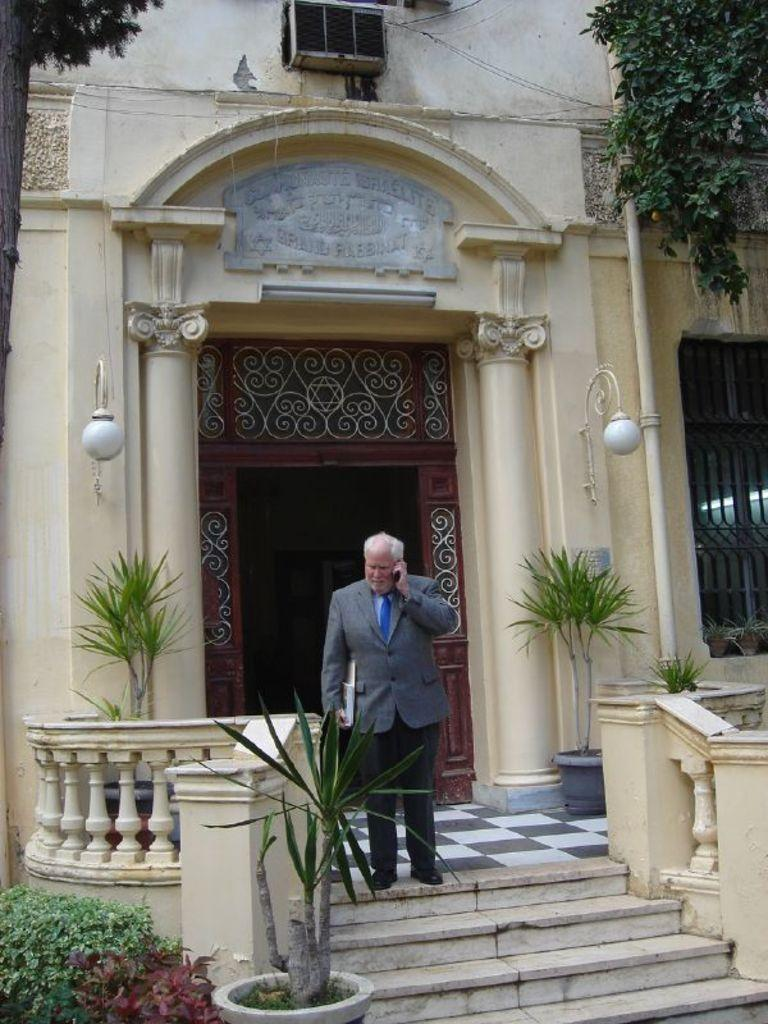What type of living organisms can be seen in the image? Plants can be seen in the image. What structure is visible in the background of the image? There is a house in the background of the image. Can you describe the person in the image? There is a man standing in front of the house. What page of the book does the caption refer to in the image? There is no book or caption present in the image. 